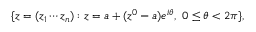Convert formula to latex. <formula><loc_0><loc_0><loc_500><loc_500>\{ z = ( z _ { 1 } \cdots z _ { n } ) \colon z = a + ( z ^ { 0 } - a ) e ^ { i \theta } , \ 0 \leq \theta < 2 \pi \} ,</formula> 